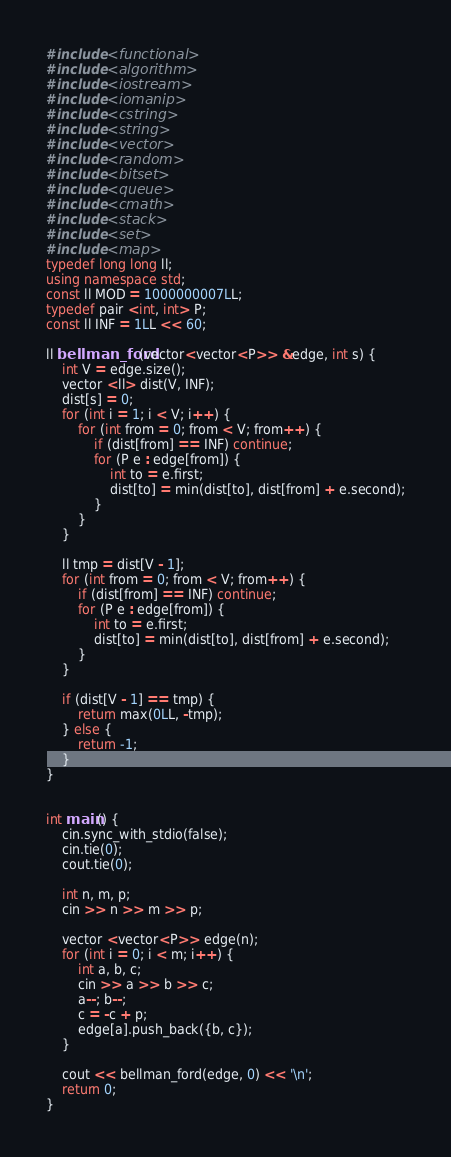<code> <loc_0><loc_0><loc_500><loc_500><_C++_>#include <functional>
#include <algorithm>
#include <iostream>
#include <iomanip>
#include <cstring>
#include <string>
#include <vector>
#include <random>
#include <bitset>
#include <queue>
#include <cmath>
#include <stack>
#include <set>
#include <map>
typedef long long ll;
using namespace std;
const ll MOD = 1000000007LL;
typedef pair <int, int> P;
const ll INF = 1LL << 60;

ll bellman_ford(vector<vector<P>> &edge, int s) {
    int V = edge.size();
    vector <ll> dist(V, INF);
    dist[s] = 0;
    for (int i = 1; i < V; i++) {
        for (int from = 0; from < V; from++) {
            if (dist[from] == INF) continue;
            for (P e : edge[from]) {
                int to = e.first;
                dist[to] = min(dist[to], dist[from] + e.second);
            }
        }
    }

    ll tmp = dist[V - 1];
    for (int from = 0; from < V; from++) {
        if (dist[from] == INF) continue;
        for (P e : edge[from]) {
            int to = e.first;
            dist[to] = min(dist[to], dist[from] + e.second);
        }
    }

    if (dist[V - 1] == tmp) {
        return max(0LL, -tmp);
    } else {
        return -1;
    }
}


int main() {
    cin.sync_with_stdio(false);
    cin.tie(0);
    cout.tie(0);

    int n, m, p;
    cin >> n >> m >> p;

    vector <vector<P>> edge(n);
    for (int i = 0; i < m; i++) {
        int a, b, c;
        cin >> a >> b >> c;
        a--; b--;
        c = -c + p;
        edge[a].push_back({b, c});
    }

    cout << bellman_ford(edge, 0) << '\n';
    return 0;
}</code> 